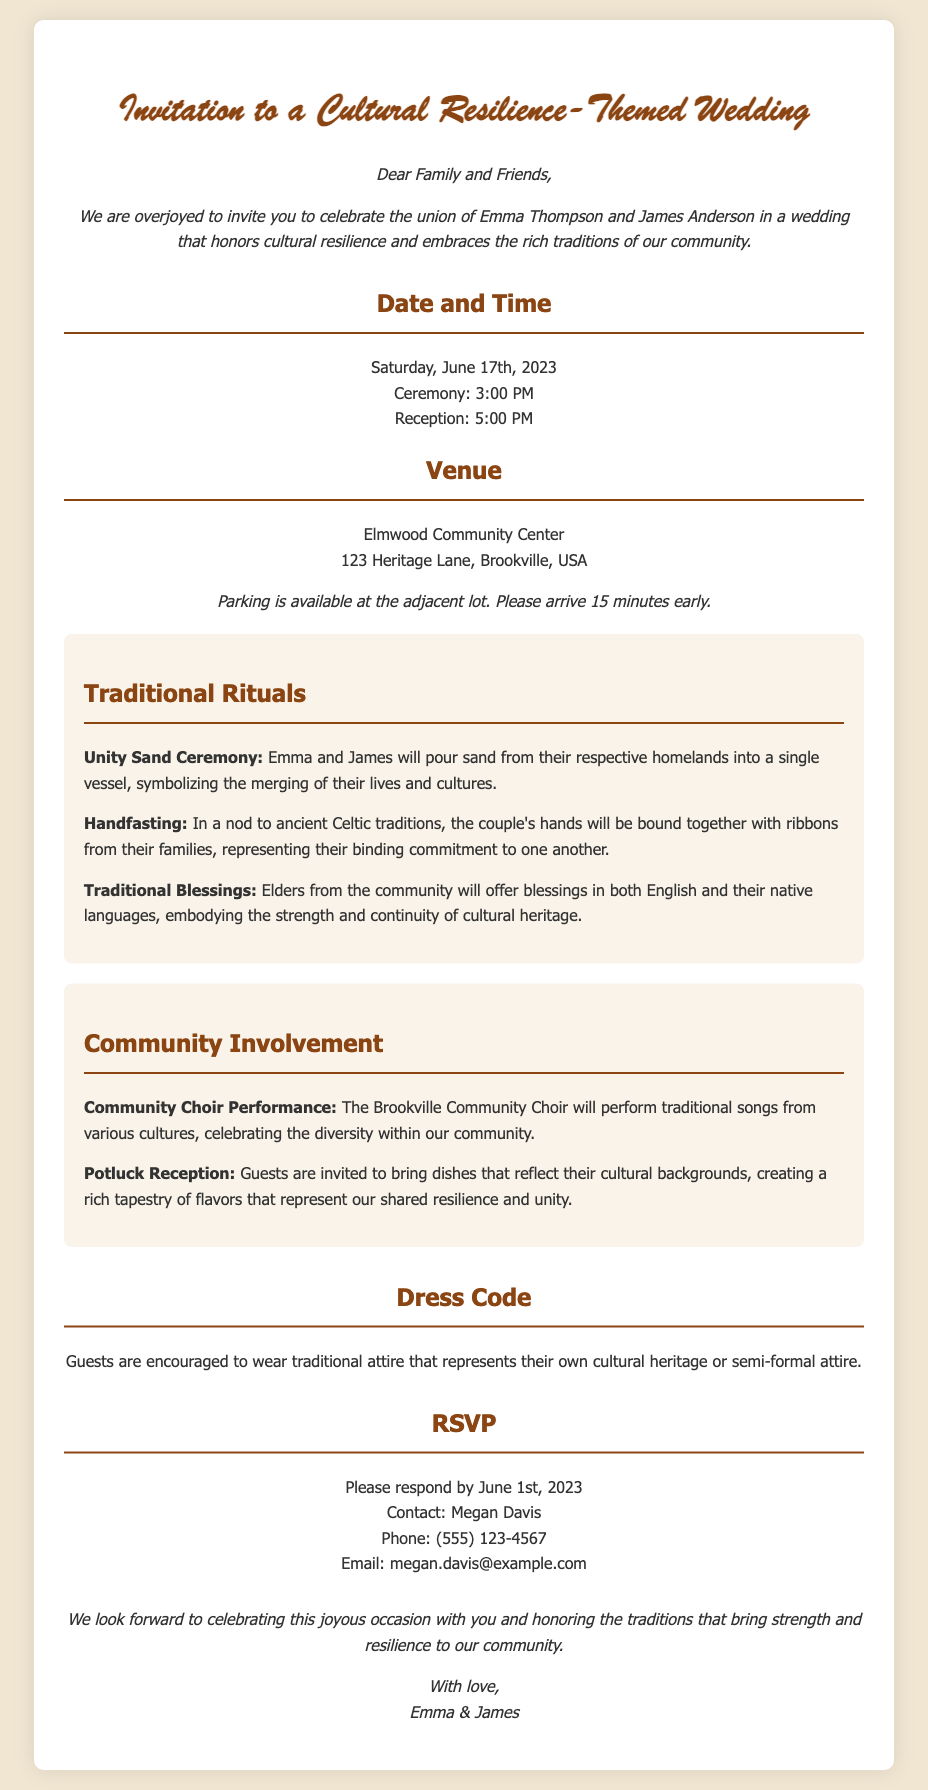What date is the wedding? The wedding date is explicitly stated in the invitation as Saturday, June 17th, 2023.
Answer: Saturday, June 17th, 2023 What are the names of the couple? The names of the couple are mentioned in the introduction of the invitation, which states their names are Emma Thompson and James Anderson.
Answer: Emma Thompson and James Anderson What time does the ceremony start? The time for the ceremony is explicitly mentioned in the date-time section as 3:00 PM.
Answer: 3:00 PM What is the venue for the wedding? The venue is specified in the venue section of the invitation, identifying the Elmwood Community Center as the location.
Answer: Elmwood Community Center What traditional ritual involves sand? The invitation mentions the "Unity Sand Ceremony" as a traditional ritual that involves pouring sand from their respective homelands.
Answer: Unity Sand Ceremony What type of reception is being held? The invitation specifies that a potluck reception will take place, inviting guests to bring dishes reflecting their cultural backgrounds.
Answer: Potluck Reception What is the dress code for guests? The dress code requires guests to wear either traditional attire or semi-formal attire as stated in the dress code section of the invitation.
Answer: Traditional attire or semi-formal attire Who should guests contact to RSVP? The RSVP section of the invitation clearly states that Megan Davis is the contact person for guests to respond to.
Answer: Megan Davis When is the RSVP deadline? The RSVP deadline is mentioned in the RSVP section of the invitation as June 1st, 2023.
Answer: June 1st, 2023 